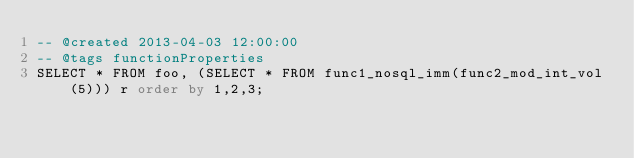<code> <loc_0><loc_0><loc_500><loc_500><_SQL_>-- @created 2013-04-03 12:00:00
-- @tags functionProperties 
SELECT * FROM foo, (SELECT * FROM func1_nosql_imm(func2_mod_int_vol(5))) r order by 1,2,3; 
</code> 